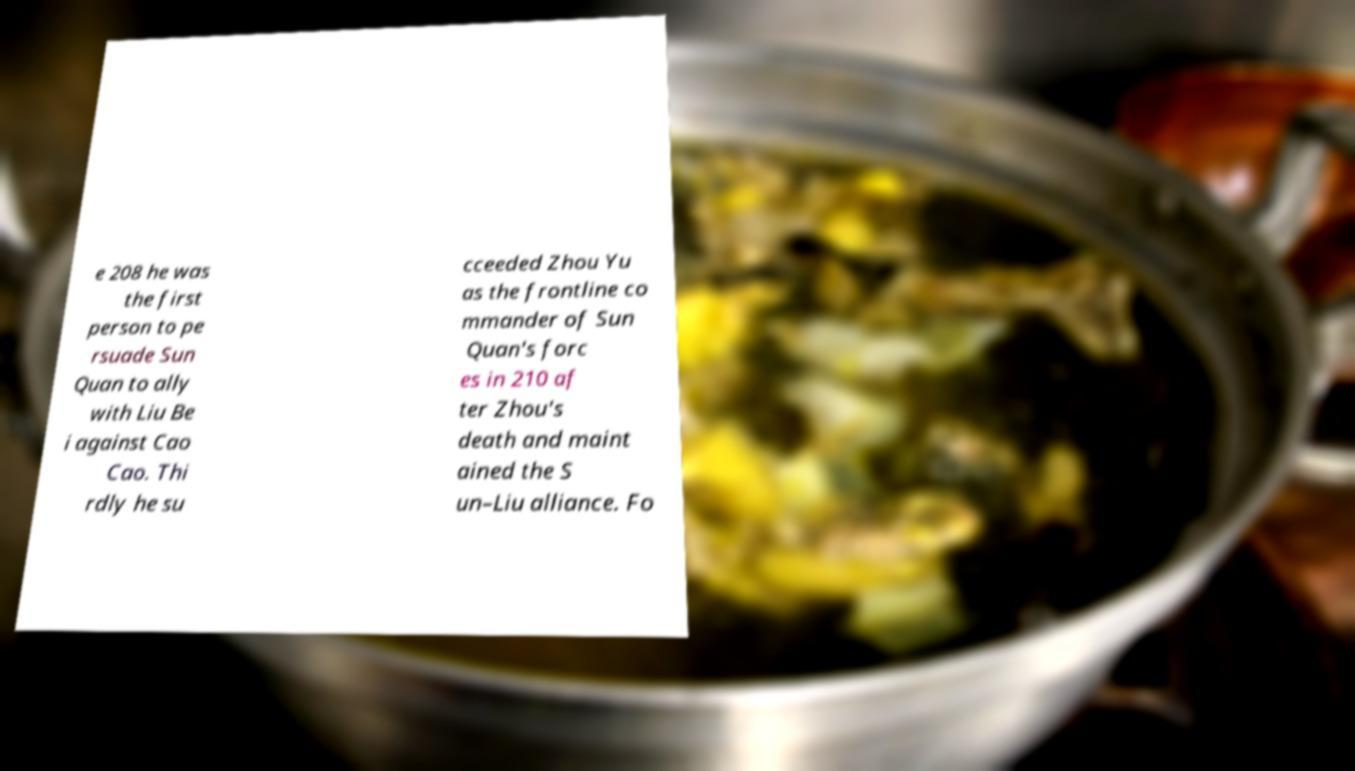For documentation purposes, I need the text within this image transcribed. Could you provide that? e 208 he was the first person to pe rsuade Sun Quan to ally with Liu Be i against Cao Cao. Thi rdly he su cceeded Zhou Yu as the frontline co mmander of Sun Quan's forc es in 210 af ter Zhou's death and maint ained the S un–Liu alliance. Fo 